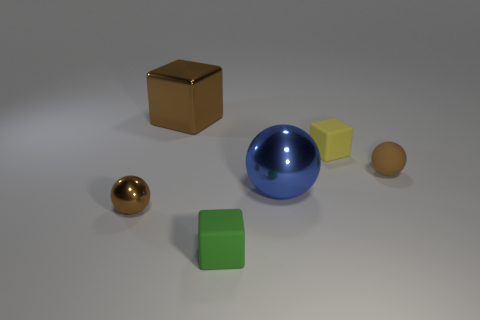Add 1 brown metal objects. How many objects exist? 7 Subtract all large blue shiny balls. Subtract all small brown things. How many objects are left? 3 Add 6 tiny green blocks. How many tiny green blocks are left? 7 Add 2 green blocks. How many green blocks exist? 3 Subtract 0 gray cylinders. How many objects are left? 6 